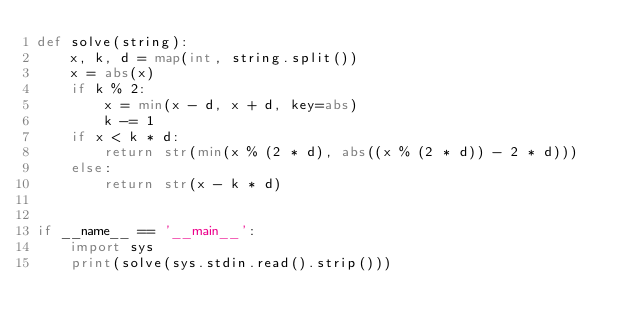Convert code to text. <code><loc_0><loc_0><loc_500><loc_500><_Python_>def solve(string):
    x, k, d = map(int, string.split())
    x = abs(x)
    if k % 2:
        x = min(x - d, x + d, key=abs)
        k -= 1
    if x < k * d:
        return str(min(x % (2 * d), abs((x % (2 * d)) - 2 * d)))
    else:
        return str(x - k * d)


if __name__ == '__main__':
    import sys
    print(solve(sys.stdin.read().strip()))
</code> 